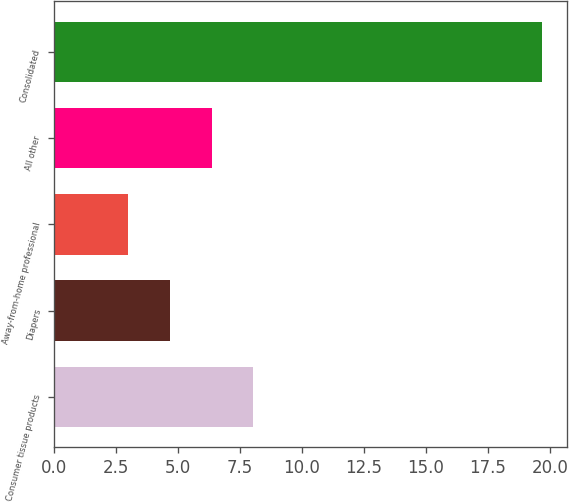<chart> <loc_0><loc_0><loc_500><loc_500><bar_chart><fcel>Consumer tissue products<fcel>Diapers<fcel>Away-from-home professional<fcel>All other<fcel>Consolidated<nl><fcel>8.04<fcel>4.7<fcel>3<fcel>6.37<fcel>19.7<nl></chart> 